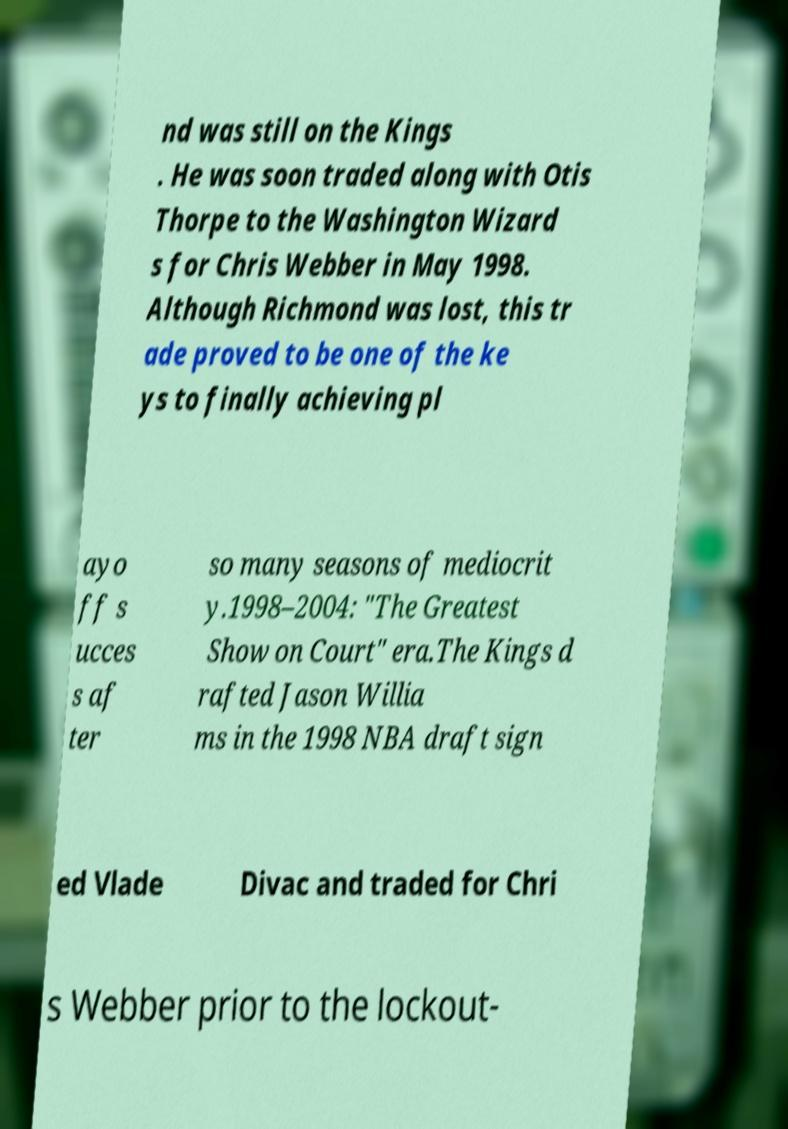Please read and relay the text visible in this image. What does it say? nd was still on the Kings . He was soon traded along with Otis Thorpe to the Washington Wizard s for Chris Webber in May 1998. Although Richmond was lost, this tr ade proved to be one of the ke ys to finally achieving pl ayo ff s ucces s af ter so many seasons of mediocrit y.1998–2004: "The Greatest Show on Court" era.The Kings d rafted Jason Willia ms in the 1998 NBA draft sign ed Vlade Divac and traded for Chri s Webber prior to the lockout- 